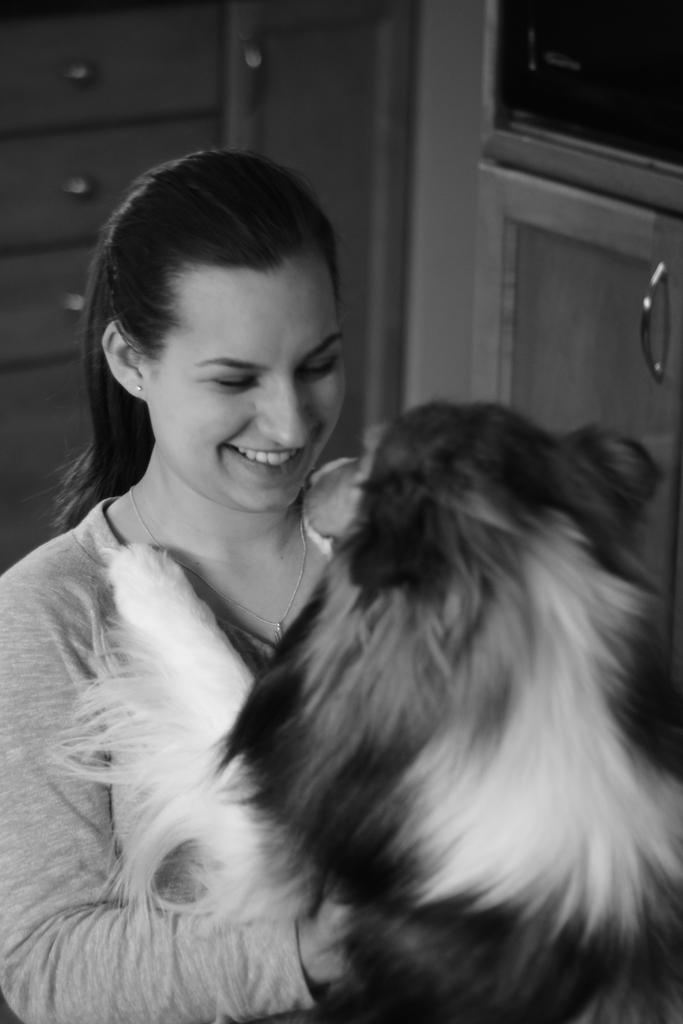What is the woman in the image holding? The woman is holding a dog. What is the group of people doing in front of the building? The transcript does not specify the activity of the group of people, so we cannot definitively answer this question. What color is the car parked on the side of the road? The facts do not mention the color of the car, so we cannot definitively answer this question. What type of chair is the cat sitting on? The facts do not specify the type of chair, so we cannot definitively answer this question. What is the person riding a bicycle wearing? The facts do not mention the clothing of the person riding a bicycle, so we cannot definitively answer this question. Absurd Question/Answer: How many slaves are visible in the image? There is no mention of slaves in the image, so we cannot definitively answer this question. 